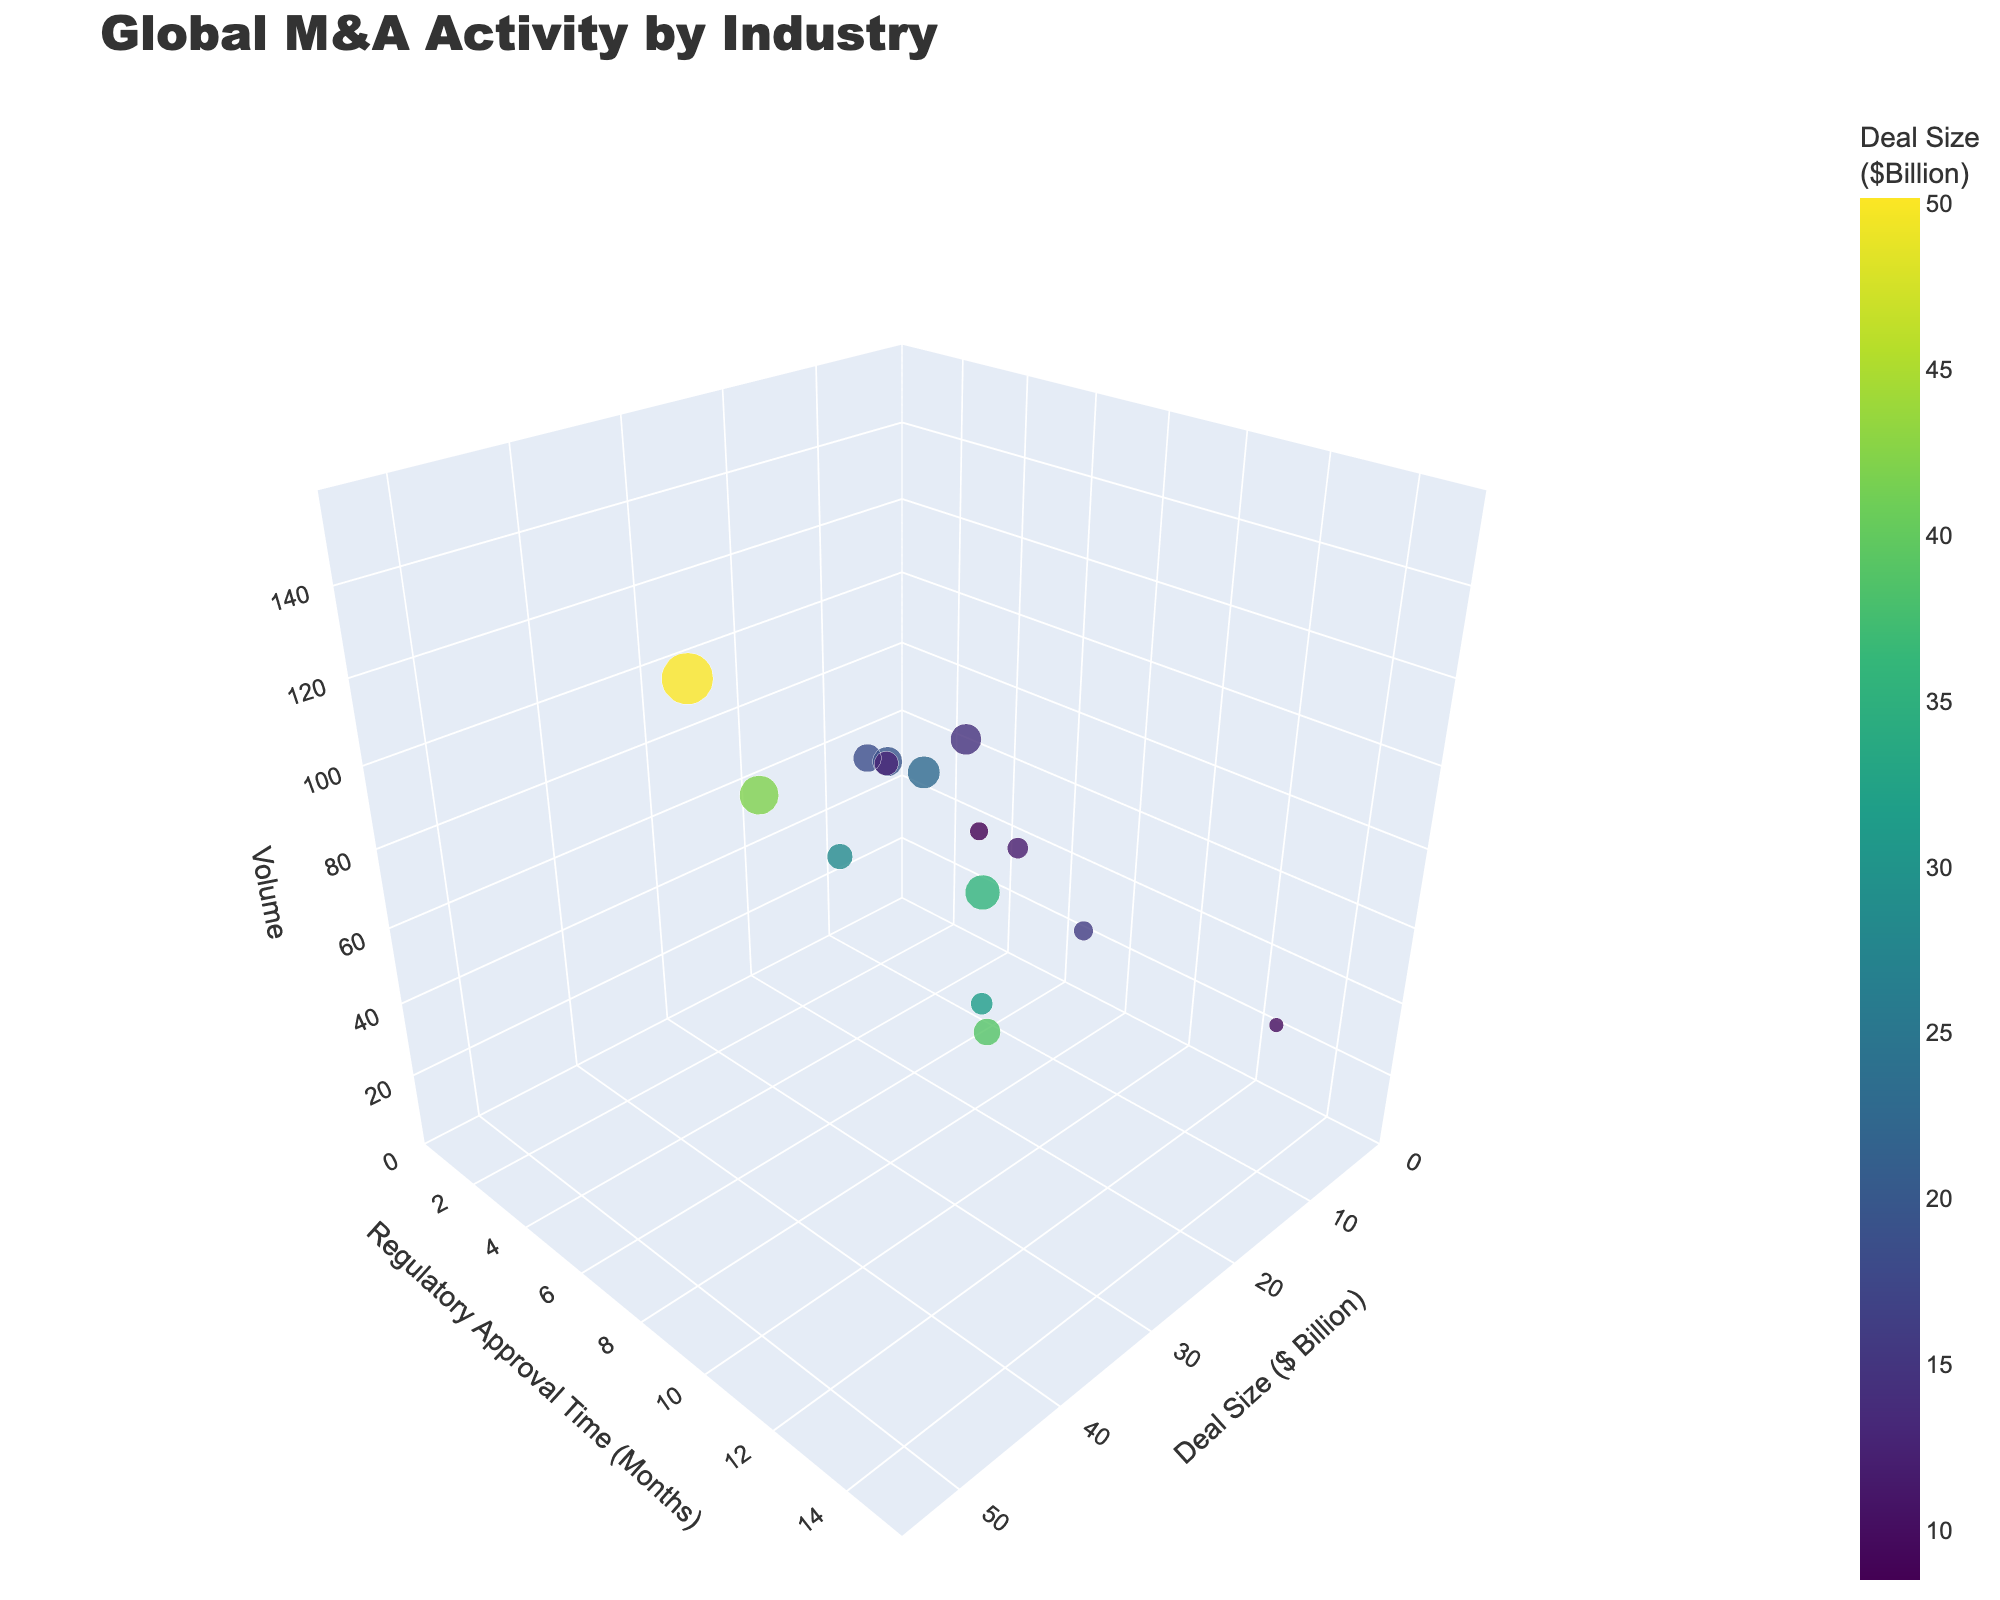What's the title of the figure? The title is a basic element of the figure and is usually located at the top of the chart.
Answer: Global M&A Activity by Industry Which industry has the highest volume of mergers and acquisitions? To determine this, look at the z-axis (Volume) and find the highest data point, then refer to the industry name provided in the hover information.
Answer: Technology What is the deal size for the Healthcare industry? Hover over the data point labeled "Healthcare" to get the exact value for Deal Size ($ Billion) from the hover information.
Answer: 35.7 Which industry has the smallest regulatory approval time and what is it? Look for the data point that positions at the lowest value on the y-axis (Regulatory Approval Time), then refer to the industry name hover information.
Answer: Real Estate, 3 months Compare the deal size of Telecommunications and Manufacturing industries. Hover over the data points labeled "Telecommunications" and "Manufacturing" to compare their Deal Size ($ Billion) values.
Answer: Telecommunications: 31.5B, Manufacturing: 22.8B What's the total volume of mergers and acquisitions for Consumer Goods and Retail industries combined? Find the volume for each industry and add them together. Consumer Goods: 83, Retail: 87, thus, 83 + 87 = 170.
Answer: 170 Which industry has more volume: Aerospace or Agriculture? Compare the volumes of the two data points labeled "Aerospace" and "Agriculture." Aerospace has a volume of 41, and Agriculture has a volume of 52.
Answer: Agriculture What is the relationship between deal size and regulatory approval time for the Pharmaceuticals industry? Hover over the Pharmaceuticals data point to identify the Deal Size ($ Billion) and Regulatory Approval Time. Pharmaceuticals has a deal size of 38.9B and a regulatory approval time of 13 months, indicating a relatively high approval time compared to deal size.
Answer: High approval time compared to deal size How does the M&A volume for Financial Services compare to that of Energy? Hover over the data points labeled "Financial Services" and "Energy" to compare their volumes. Financial Services has a volume of 110, while Energy has a volume of 72.
Answer: Financial Services What industry is represented by a point with a regulatory approval time of 10 months and what is its volume? Locate the data point on the y-axis at 10 months and check its label for the industry name and volume information. The point represents the Automotive industry with a volume of 55.
Answer: Automotive, 55 